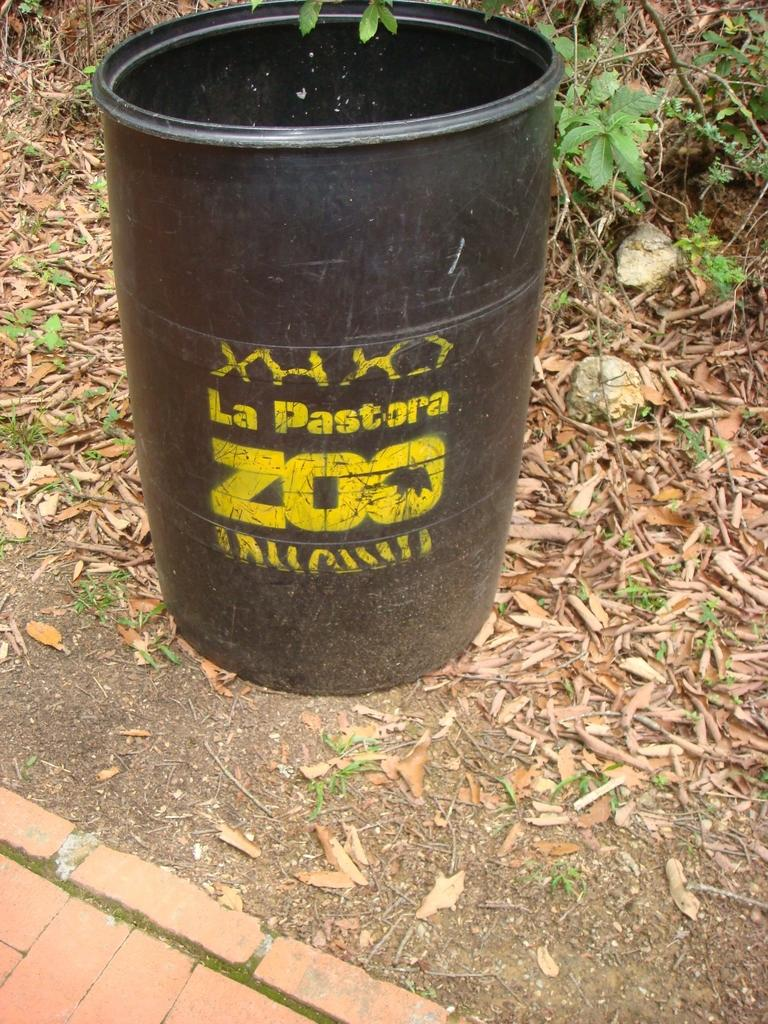<image>
Share a concise interpretation of the image provided. The black and yellow barrel is from La Pastora Zoo. 